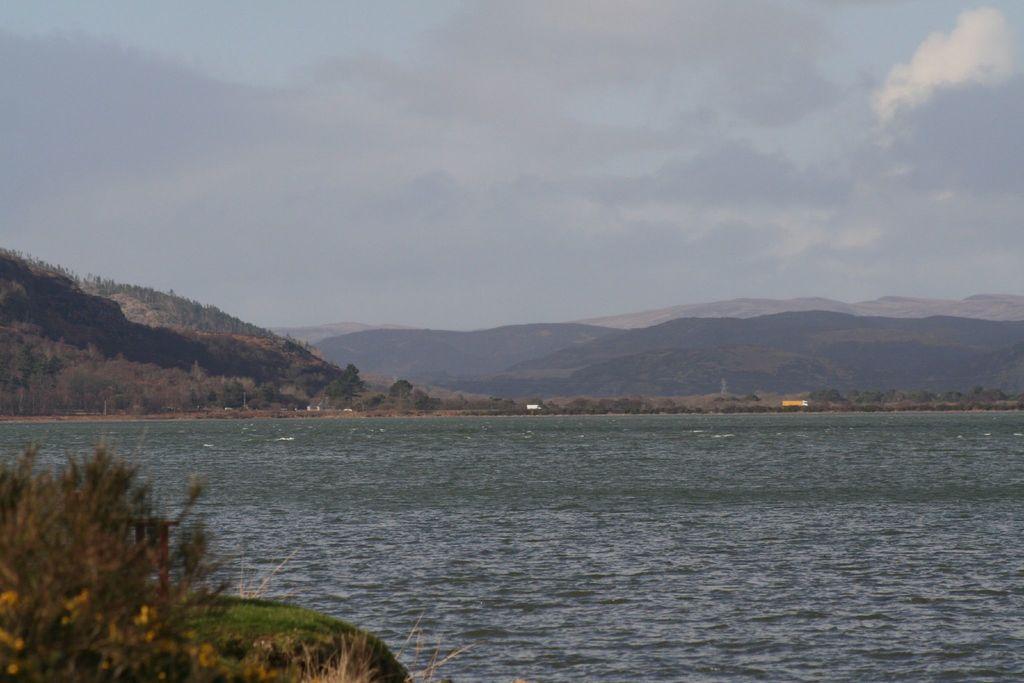In one or two sentences, can you explain what this image depicts? In this image we can see sky with clouds, hills, motor vehicles, river and plants. 